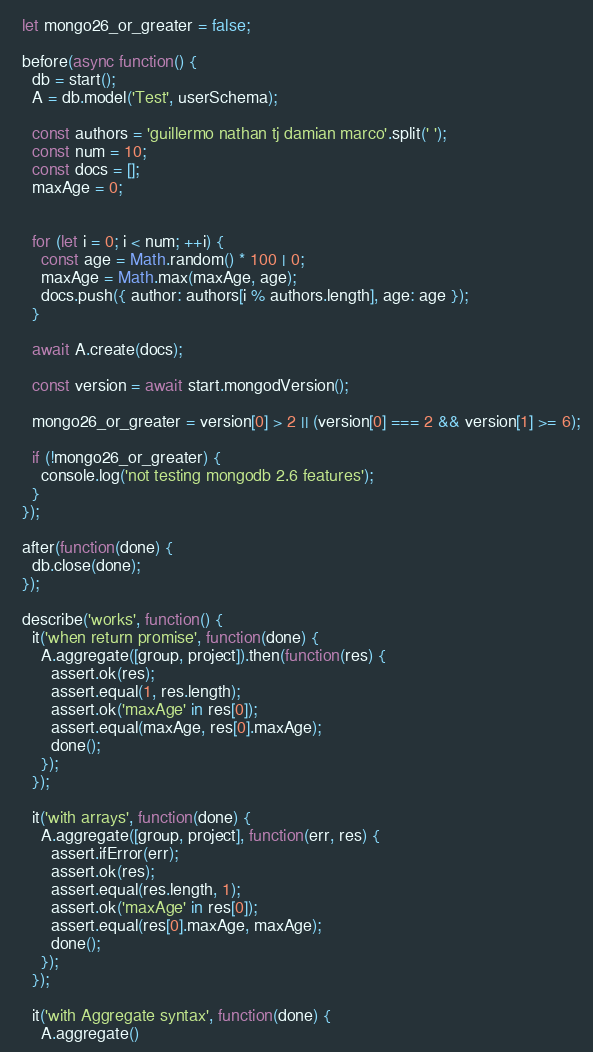Convert code to text. <code><loc_0><loc_0><loc_500><loc_500><_JavaScript_>
  let mongo26_or_greater = false;

  before(async function() {
    db = start();
    A = db.model('Test', userSchema);

    const authors = 'guillermo nathan tj damian marco'.split(' ');
    const num = 10;
    const docs = [];
    maxAge = 0;


    for (let i = 0; i < num; ++i) {
      const age = Math.random() * 100 | 0;
      maxAge = Math.max(maxAge, age);
      docs.push({ author: authors[i % authors.length], age: age });
    }

    await A.create(docs);

    const version = await start.mongodVersion();

    mongo26_or_greater = version[0] > 2 || (version[0] === 2 && version[1] >= 6);

    if (!mongo26_or_greater) {
      console.log('not testing mongodb 2.6 features');
    }
  });

  after(function(done) {
    db.close(done);
  });

  describe('works', function() {
    it('when return promise', function(done) {
      A.aggregate([group, project]).then(function(res) {
        assert.ok(res);
        assert.equal(1, res.length);
        assert.ok('maxAge' in res[0]);
        assert.equal(maxAge, res[0].maxAge);
        done();
      });
    });

    it('with arrays', function(done) {
      A.aggregate([group, project], function(err, res) {
        assert.ifError(err);
        assert.ok(res);
        assert.equal(res.length, 1);
        assert.ok('maxAge' in res[0]);
        assert.equal(res[0].maxAge, maxAge);
        done();
      });
    });

    it('with Aggregate syntax', function(done) {
      A.aggregate()</code> 